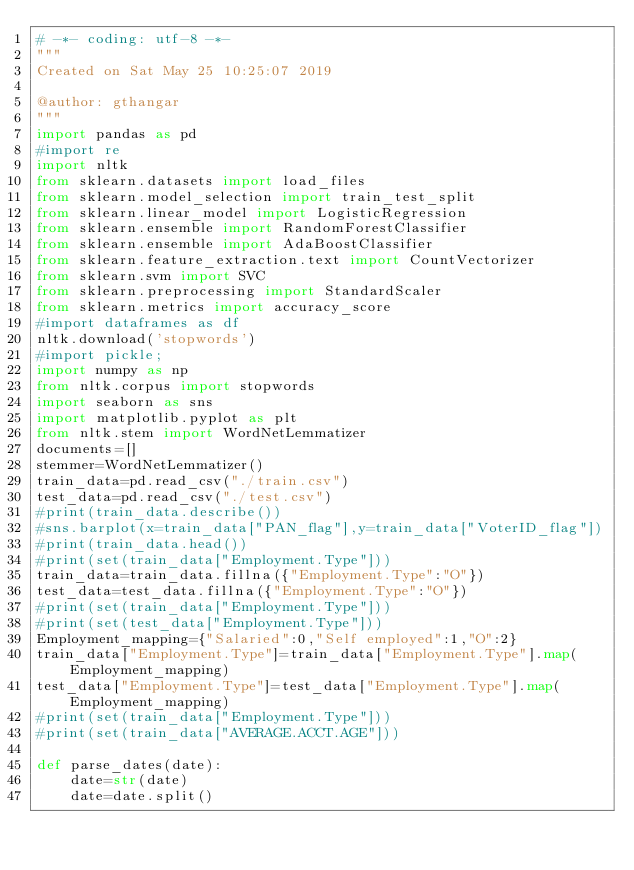<code> <loc_0><loc_0><loc_500><loc_500><_Python_># -*- coding: utf-8 -*-
"""
Created on Sat May 25 10:25:07 2019

@author: gthangar
"""
import pandas as pd
#import re
import nltk
from sklearn.datasets import load_files
from sklearn.model_selection import train_test_split
from sklearn.linear_model import LogisticRegression
from sklearn.ensemble import RandomForestClassifier
from sklearn.ensemble import AdaBoostClassifier
from sklearn.feature_extraction.text import CountVectorizer
from sklearn.svm import SVC
from sklearn.preprocessing import StandardScaler
from sklearn.metrics import accuracy_score
#import dataframes as df
nltk.download('stopwords')
#import pickle;
import numpy as np
from nltk.corpus import stopwords
import seaborn as sns
import matplotlib.pyplot as plt
from nltk.stem import WordNetLemmatizer
documents=[]
stemmer=WordNetLemmatizer()
train_data=pd.read_csv("./train.csv")
test_data=pd.read_csv("./test.csv")
#print(train_data.describe())
#sns.barplot(x=train_data["PAN_flag"],y=train_data["VoterID_flag"])
#print(train_data.head())
#print(set(train_data["Employment.Type"]))
train_data=train_data.fillna({"Employment.Type":"O"})
test_data=test_data.fillna({"Employment.Type":"O"})
#print(set(train_data["Employment.Type"]))
#print(set(test_data["Employment.Type"]))
Employment_mapping={"Salaried":0,"Self employed":1,"O":2}
train_data["Employment.Type"]=train_data["Employment.Type"].map(Employment_mapping)
test_data["Employment.Type"]=test_data["Employment.Type"].map(Employment_mapping)
#print(set(train_data["Employment.Type"]))
#print(set(train_data["AVERAGE.ACCT.AGE"]))

def parse_dates(date):
    date=str(date)
    date=date.split()</code> 